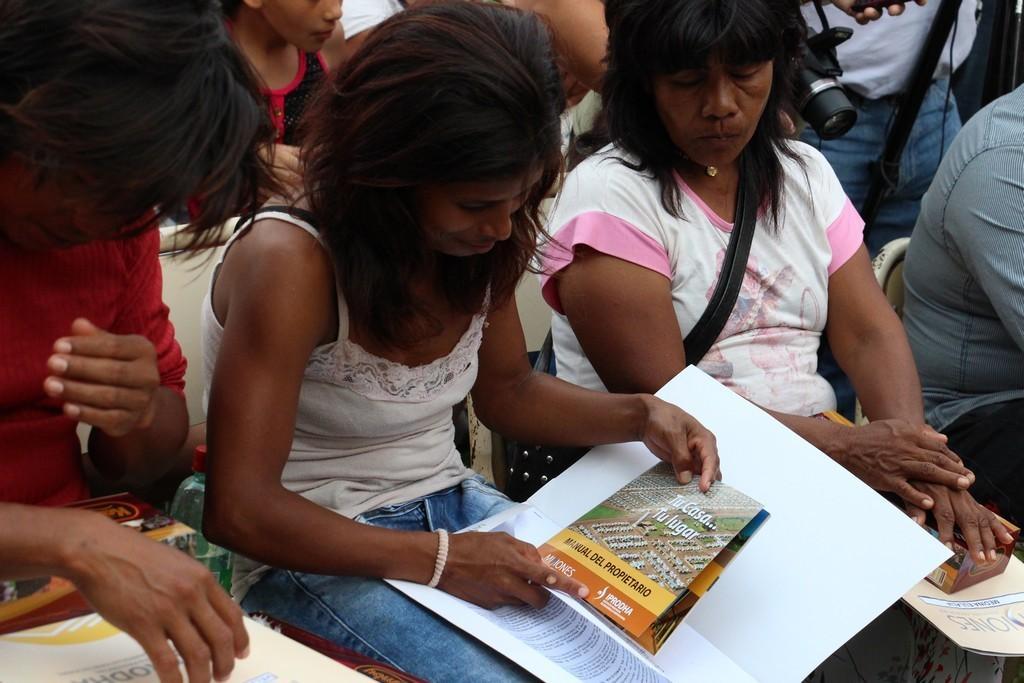Could you give a brief overview of what you see in this image? In this image I see few people who are sitting on chairs and I see that this woman is holding a paper in her hand and I see few more papers over here and I see a camera over here. 